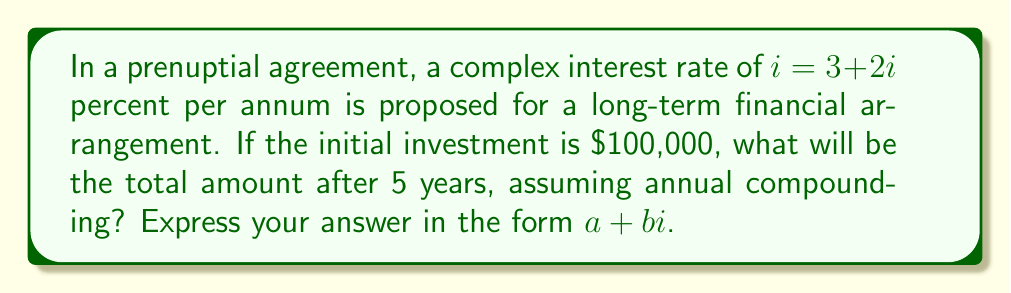Give your solution to this math problem. To solve this problem, we'll follow these steps:

1) First, we need to convert the complex interest rate to a decimal form:
   $i = (3 + 2i)\% = 0.03 + 0.02i$

2) The formula for compound interest with a complex rate is:
   $A = P(1 + i)^n$
   Where $A$ is the final amount, $P$ is the principal, $i$ is the interest rate, and $n$ is the number of years.

3) Substituting our values:
   $A = 100000(1 + 0.03 + 0.02i)^5$

4) Let's expand $(1 + 0.03 + 0.02i)^5$ using the binomial theorem:
   $$(1 + 0.03 + 0.02i)^5 = 1 + 5(0.03 + 0.02i) + 10(0.03 + 0.02i)^2 + 10(0.03 + 0.02i)^3 + 5(0.03 + 0.02i)^4 + (0.03 + 0.02i)^5$$

5) Expanding and simplifying (keeping only terms up to $i^2$, as higher powers of $i$ can be reduced):
   $$(1 + 0.03 + 0.02i)^5 \approx 1 + 0.15 + 0.1i + 0.0225 + 0.03i - 0.002 + 0.00225 + 0.003i - 0.0002i = 1.17275 + 0.133i$$

6) Now, multiplying by the principal:
   $A = 100000(1.17275 + 0.133i) = 117275 + 13300i$
Answer: $117275 + 13300i$ 